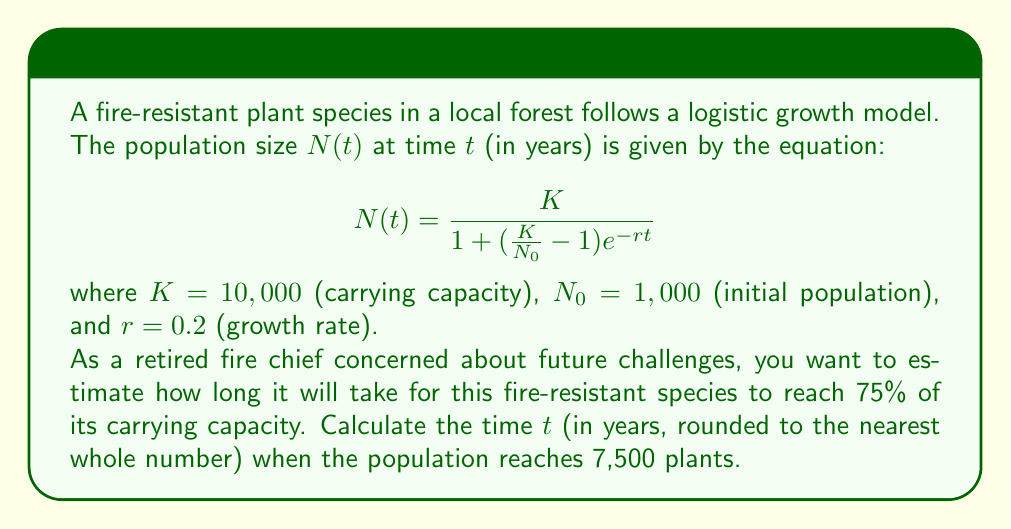Give your solution to this math problem. To solve this problem, we need to use the logistic growth equation and solve for $t$ when $N(t) = 7,500$.

1. Start with the logistic growth equation:
   $$N(t) = \frac{K}{1 + (\frac{K}{N_0} - 1)e^{-rt}}$$

2. Substitute the known values:
   $K = 10,000$, $N_0 = 1,000$, $r = 0.2$, and $N(t) = 7,500$

3. Set up the equation:
   $$7,500 = \frac{10,000}{1 + (\frac{10,000}{1,000} - 1)e^{-0.2t}}$$

4. Simplify:
   $$7,500 = \frac{10,000}{1 + 9e^{-0.2t}}$$

5. Multiply both sides by $(1 + 9e^{-0.2t})$:
   $$7,500(1 + 9e^{-0.2t}) = 10,000$$

6. Expand:
   $$7,500 + 67,500e^{-0.2t} = 10,000$$

7. Subtract 7,500 from both sides:
   $$67,500e^{-0.2t} = 2,500$$

8. Divide both sides by 67,500:
   $$e^{-0.2t} = \frac{2,500}{67,500} = \frac{1}{27}$$

9. Take the natural logarithm of both sides:
   $$-0.2t = \ln(\frac{1}{27})$$

10. Solve for $t$:
    $$t = -\frac{\ln(\frac{1}{27})}{0.2} = \frac{\ln(27)}{0.2}$$

11. Calculate the result:
    $$t \approx 16.52$$

12. Round to the nearest whole number:
    $$t \approx 17$$

Therefore, it will take approximately 17 years for the fire-resistant plant species to reach 75% of its carrying capacity.
Answer: 17 years 